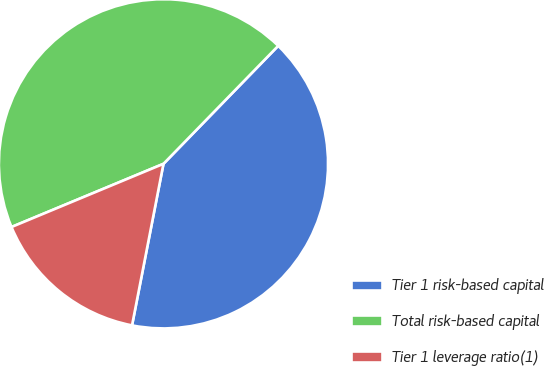Convert chart to OTSL. <chart><loc_0><loc_0><loc_500><loc_500><pie_chart><fcel>Tier 1 risk-based capital<fcel>Total risk-based capital<fcel>Tier 1 leverage ratio(1)<nl><fcel>40.78%<fcel>43.55%<fcel>15.67%<nl></chart> 